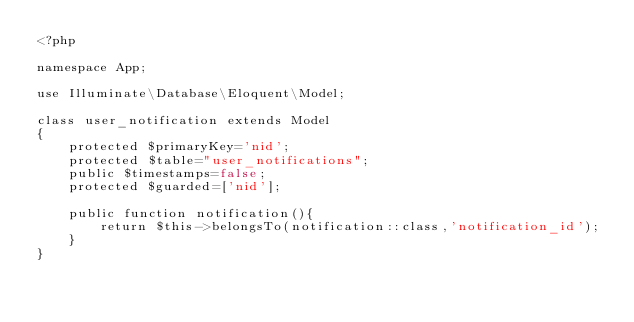<code> <loc_0><loc_0><loc_500><loc_500><_PHP_><?php

namespace App;

use Illuminate\Database\Eloquent\Model;

class user_notification extends Model
{
    protected $primaryKey='nid';
    protected $table="user_notifications";
    public $timestamps=false;
    protected $guarded=['nid'];

    public function notification(){
        return $this->belongsTo(notification::class,'notification_id');
    }
}
</code> 